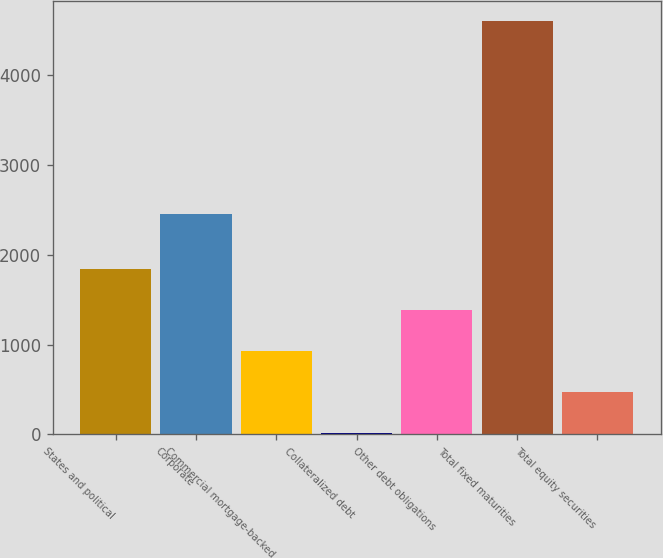Convert chart to OTSL. <chart><loc_0><loc_0><loc_500><loc_500><bar_chart><fcel>States and political<fcel>Corporate<fcel>Commercial mortgage-backed<fcel>Collateralized debt<fcel>Other debt obligations<fcel>Total fixed maturities<fcel>Total equity securities<nl><fcel>1845.32<fcel>2457.4<fcel>927.86<fcel>10.4<fcel>1386.59<fcel>4597.7<fcel>469.13<nl></chart> 